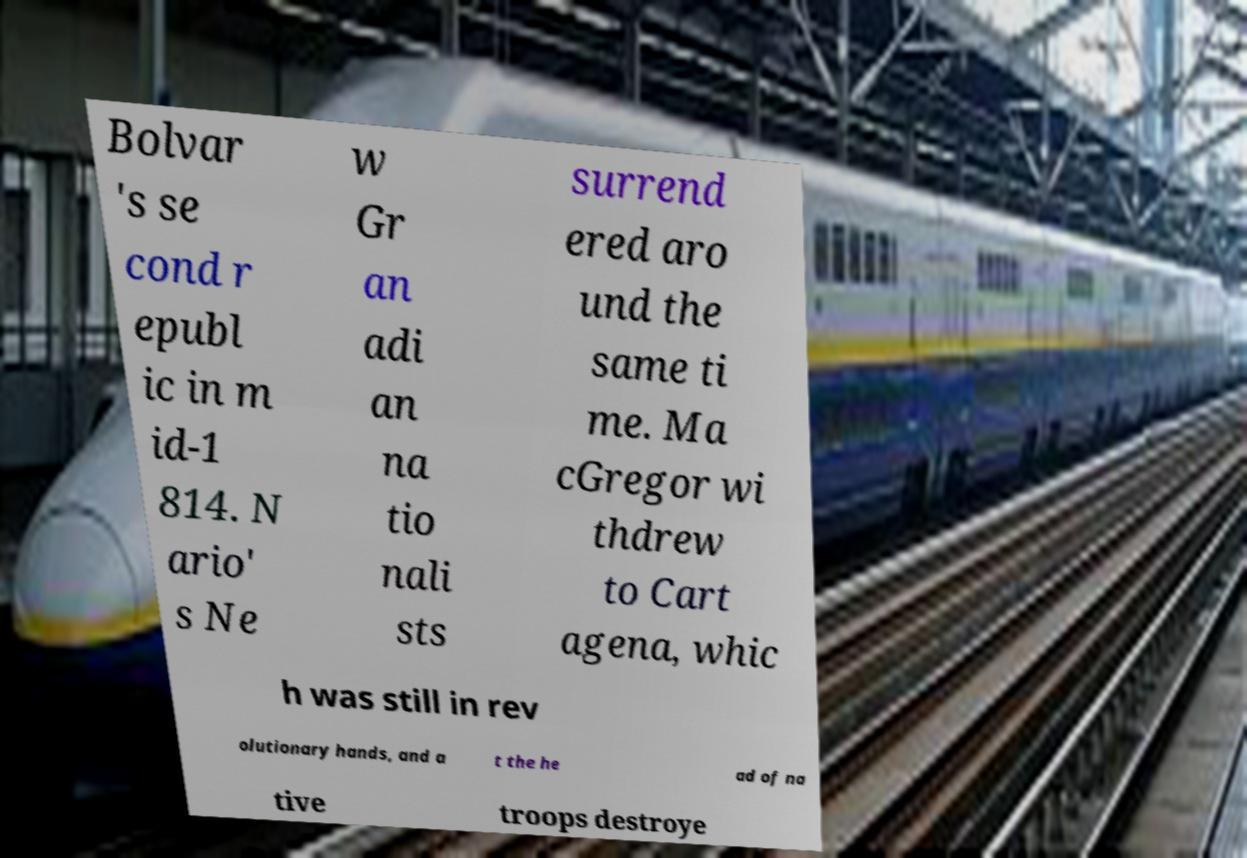There's text embedded in this image that I need extracted. Can you transcribe it verbatim? Bolvar 's se cond r epubl ic in m id-1 814. N ario' s Ne w Gr an adi an na tio nali sts surrend ered aro und the same ti me. Ma cGregor wi thdrew to Cart agena, whic h was still in rev olutionary hands, and a t the he ad of na tive troops destroye 